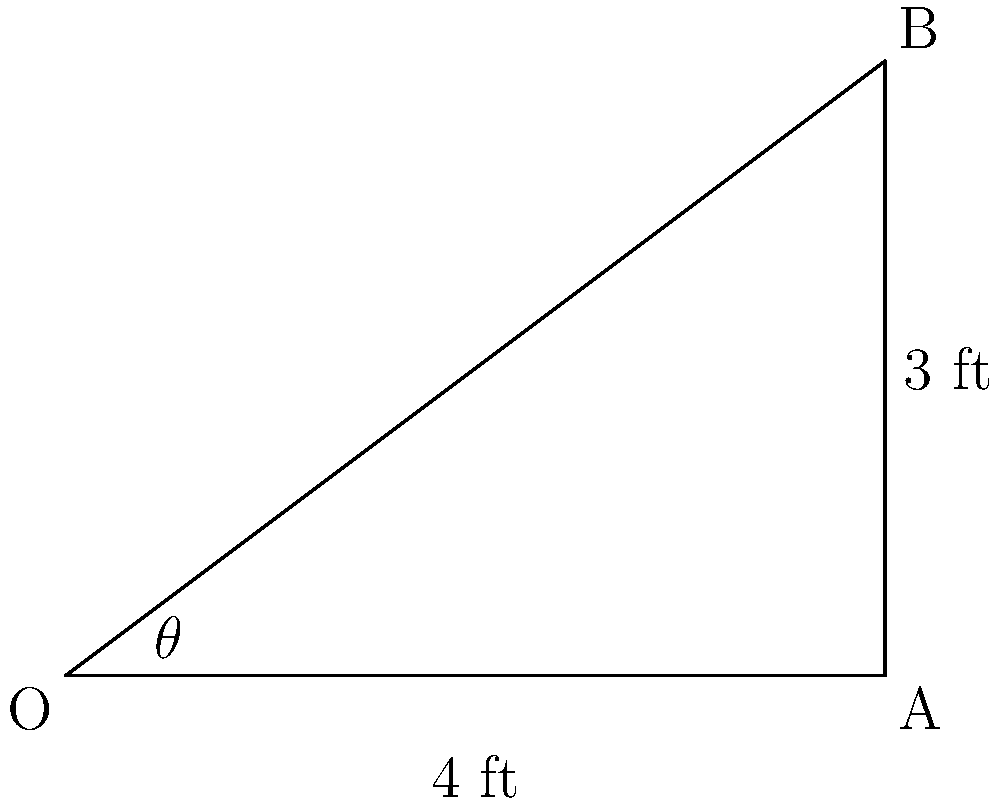As a weightlifting enthusiast, you're designing a custom bench for optimal muscle engagement. The bench's base is 4 feet long, and you want the highest point to be 3 feet above the base. What is the optimal angle $\theta$ (in degrees) between the bench and the ground to achieve this configuration? To solve this problem, we'll use trigonometry:

1) We have a right triangle with the following measurements:
   - Base (adjacent to angle $\theta$): 4 feet
   - Height (opposite to angle $\theta$): 3 feet

2) We can use the tangent function to find the angle:

   $\tan(\theta) = \frac{\text{opposite}}{\text{adjacent}} = \frac{3}{4}$

3) To find $\theta$, we need to use the inverse tangent (arctan or $\tan^{-1}$):

   $\theta = \tan^{-1}(\frac{3}{4})$

4) Using a calculator or trigonometric tables:

   $\theta \approx 36.87°$

5) Rounding to the nearest degree:

   $\theta \approx 37°$

This angle will provide the optimal incline for your weightlifting bench, balancing comfort and muscle engagement.
Answer: $37°$ 